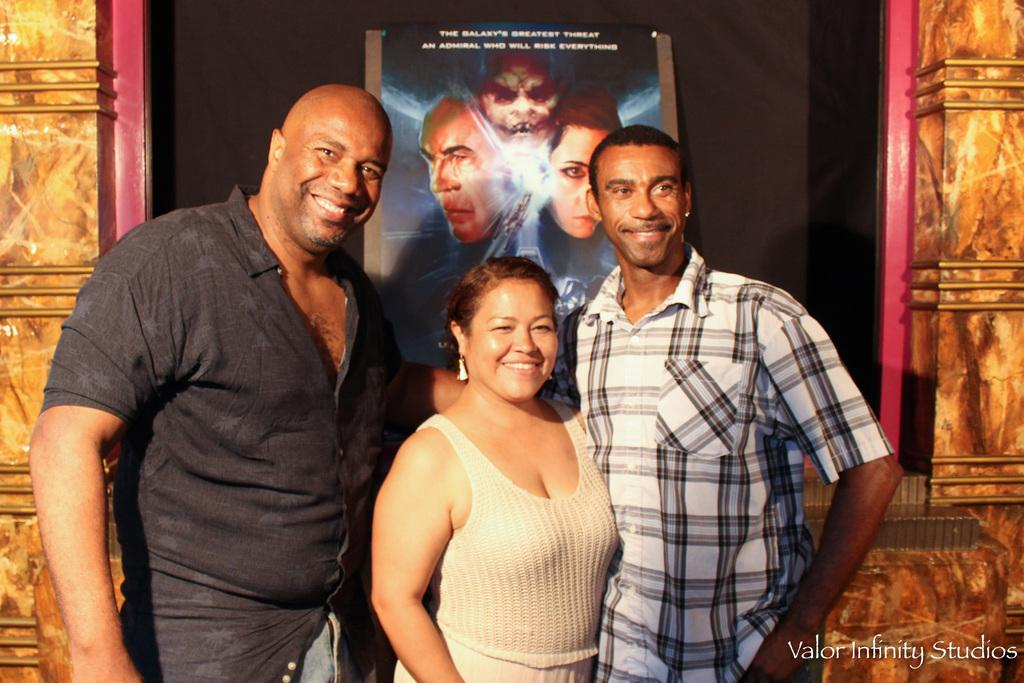How many people are in the image? There are three persons standing in the image. What is the facial expression of the people in the image? The persons are smiling. What can be seen in the background of the image? There is a poster and a wall in the background of the image. Where is the text located in the image? The text is written in the right bottom corner of the image. What type of alarm is going off in the image? There is no alarm present in the image. What type of place is depicted in the image? The image does not show a specific place; it only shows three persons standing with a background of a poster and a wall. 